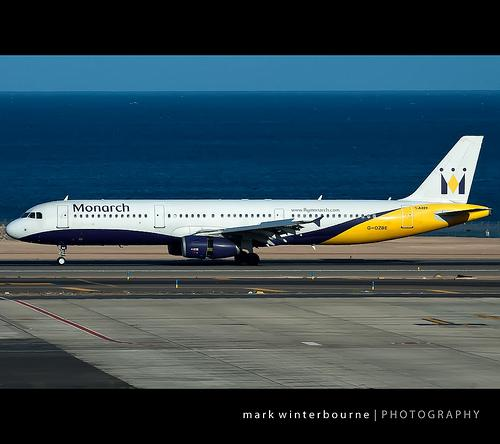What color is the engine of the airplane, and where is it located? The engine is blue and is located on the left side of the plane. Describe the markings and text present on the side of the airplane. The word "Monarch" is written on the side of the plane, and a symbol with a yellow diamond and three blue dots is present on the tail. Are there any distinct features on the tarmac of the runway? Yes, there are colorful stripes on the tarmac and a short blue and yellow post. Identify the type of transportation vehicle in the image and its location. A large commercial jetliner is parked on a runway next to a body of water. Mention three distinct colors that can be found on the airplane. Yellow, blue, and white. Analyse the interaction between the main subject and its environment. The airplane is parked on the tarmac near an ocean, emphasizing the connection between air travel and global exploration. The clear sky suggests a perfect day for travel, while the runway and surrounding environment showcase the necessary infrastructure for flight. Count the number of windows on the side of the plane and describe their position. There are 14 windows on the side of the plane, arranged in a row towards the front of the aircraft. What can be seen in the environment surrounding the airplane? There is an ocean behind the airplane, a clear sky, and an airport runway with white lines down the middle. What is the sentiment evoked by the image of the airplane on the runway? The image evokes a sense of adventure or travel, as the airplane is on the runway, ready to take off. How many wheels are visible on the airplane, and where is the front wheel located? There is one visible wheel, the front wheel, which is located below the front side door of the airplane. 